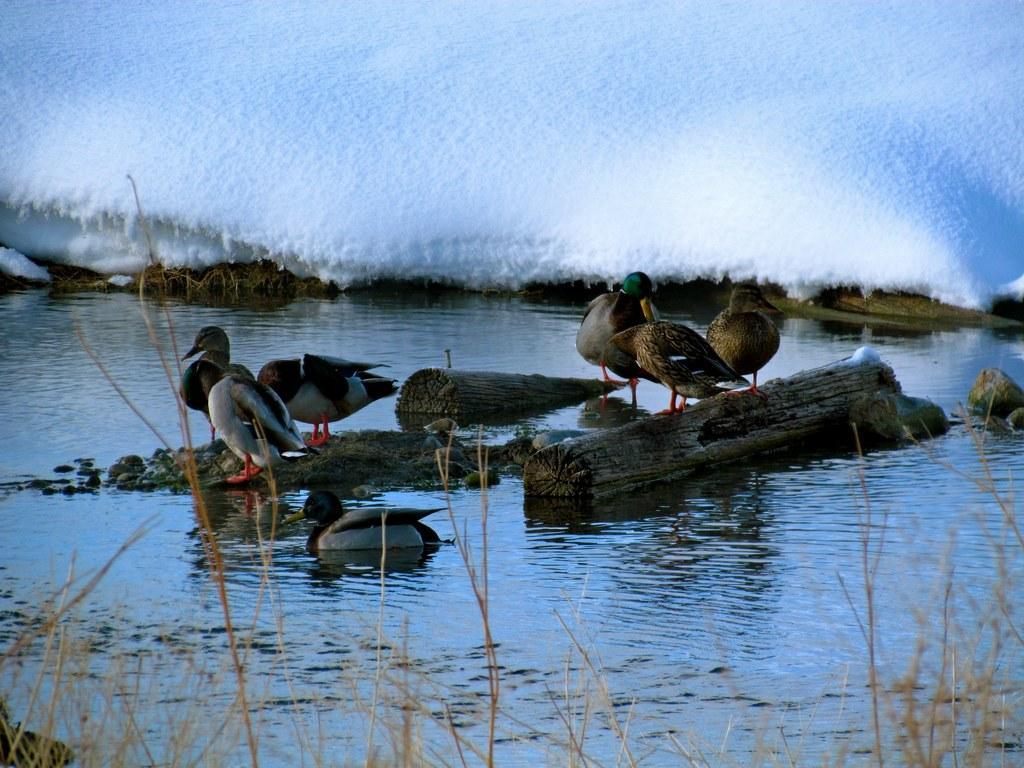Where are the birds located in the image? The birds are on the bark of a tree and on the rocks. What can be seen at the bottom of the image? There is water visible at the bottom of the image. What is the background of the image like? There is snow in the background of the image. What type of vegetation is present in the image? There are plants present in the image. What type of insect can be seen crawling on the trousers in the image? There are no trousers present in the image, and therefore no insects can be seen crawling on them. 